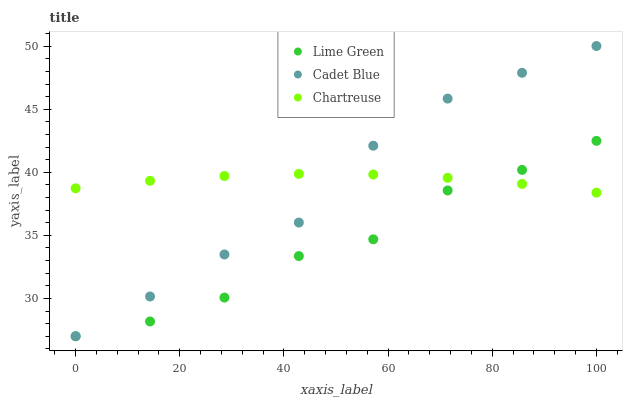Does Lime Green have the minimum area under the curve?
Answer yes or no. Yes. Does Chartreuse have the maximum area under the curve?
Answer yes or no. Yes. Does Cadet Blue have the minimum area under the curve?
Answer yes or no. No. Does Cadet Blue have the maximum area under the curve?
Answer yes or no. No. Is Chartreuse the smoothest?
Answer yes or no. Yes. Is Lime Green the roughest?
Answer yes or no. Yes. Is Cadet Blue the smoothest?
Answer yes or no. No. Is Cadet Blue the roughest?
Answer yes or no. No. Does Cadet Blue have the lowest value?
Answer yes or no. Yes. Does Cadet Blue have the highest value?
Answer yes or no. Yes. Does Lime Green have the highest value?
Answer yes or no. No. Does Cadet Blue intersect Chartreuse?
Answer yes or no. Yes. Is Cadet Blue less than Chartreuse?
Answer yes or no. No. Is Cadet Blue greater than Chartreuse?
Answer yes or no. No. 